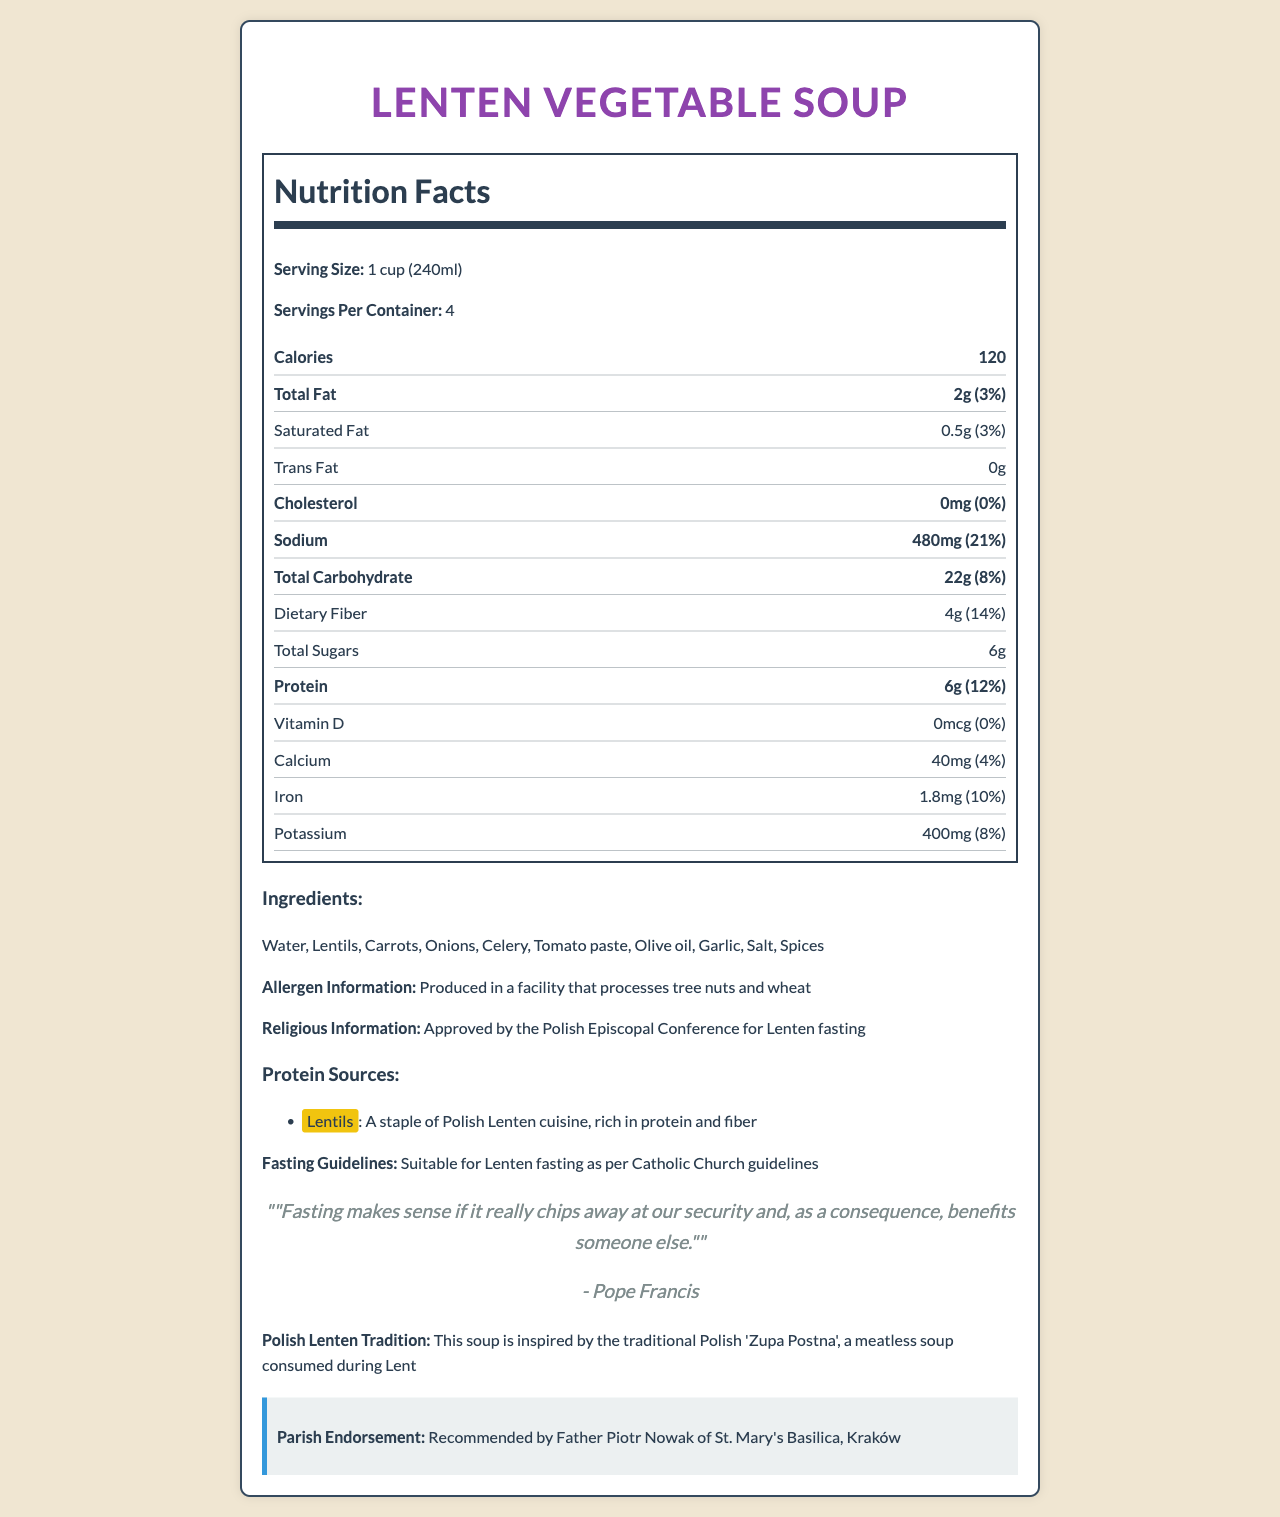What is the serving size of the Lenten Vegetable Soup? The serving size is mentioned at the beginning of the Nutrition Facts section as "Serving Size: 1 cup (240ml)."
Answer: 1 cup (240ml) How many servings per container? The document specifies "Servings Per Container: 4" below the serving size information.
Answer: 4 What percentage of the daily value for sodium does one serving of Lenten Vegetable Soup provide? The sodium content section states "Sodium: 480mg (21%)."
Answer: 21% What is the main source of protein in the Lenten Vegetable Soup? The document highlights Lentils as a key protein source with the description stating it is "rich in protein and fiber."
Answer: Lentils How many calories are in one serving of Lenten Vegetable Soup? The calorie content is stated as "Calories: 120" under the Nutrition Facts section.
Answer: 120 What is the total fat content in one serving of Lenten Vegetable Soup? A. 2g B. 0.5g C. 4g D. 8g The total fat content is listed as "Total Fat: 2g" in the document.
Answer: A. 2g What organization has approved this soup for Lenten fasting? A. The Vatican B. Polish Episcopal Conference C. Local Parish Council D. European Catholic Congress The document lists that the soup is "Approved by the Polish Episcopal Conference for Lenten fasting."
Answer: B. Polish Episcopal Conference Does the Lenten Vegetable Soup contain any cholesterol? The Cholesterol section indicates "Cholesterol: 0mg (0%)", showing that the soup contains no cholesterol.
Answer: No Summarize the document in a few sentences. The document is a detailed Nutrition Facts Label for a Lenten Vegetable Soup, approved for Lenten fasting. It includes nutritional information, ingredients, religious approval, and protein sources, placing emphasis on Lentils. A quote from Pope Francis and an endorsement by Father Piotr Nowak are also included.
Answer: The document provides nutritional information for Lenten Vegetable Soup, detailing its serving size, calories, and macronutrient content. It highlights Lentils as the primary protein source and notes the soup fits Catholic fasting guidelines. Additionally, it includes a quote from Pope Francis and endorsement from Father Piotr Nowak. What is the daily value percentage of dietary fiber in one serving of the soup? Under the dietary fiber section, the document lists "Dietary Fiber: 4g (14%)."
Answer: 14% Is the soup suitable for those who are allergic to tree nuts? The allergen information states, "Produced in a facility that processes tree nuts and wheat," so it may not be safe for those with tree nut allergies.
Answer: No How much iron is in one serving of this soup? A. 0.4mg B. 1.8mg C. 2.5mg D. 3.2mg The Iron section clearly states "Iron: 1.8mg (10%)."
Answer: B. 1.8mg What ingredient is used as the primary cooking oil in the soup? Olive oil is listed as one of the ingredients of the soup.
Answer: Olive oil How much potassium is in a serving of the soup? The potassium content is shown as "Potassium: 400mg (8%)."
Answer: 400mg What percentage of the daily value of Vitamin D does one serving of the soup contain? The vitamin section notes "Vitamin D: 0mcg (0%)."
Answer: 0% Can the total amount of spices used in the soup be determined from the document? The document lists "Spices" as an ingredient but does not specify the amount used.
Answer: Cannot be determined 